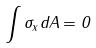Convert formula to latex. <formula><loc_0><loc_0><loc_500><loc_500>\int \sigma _ { x } d A = 0</formula> 